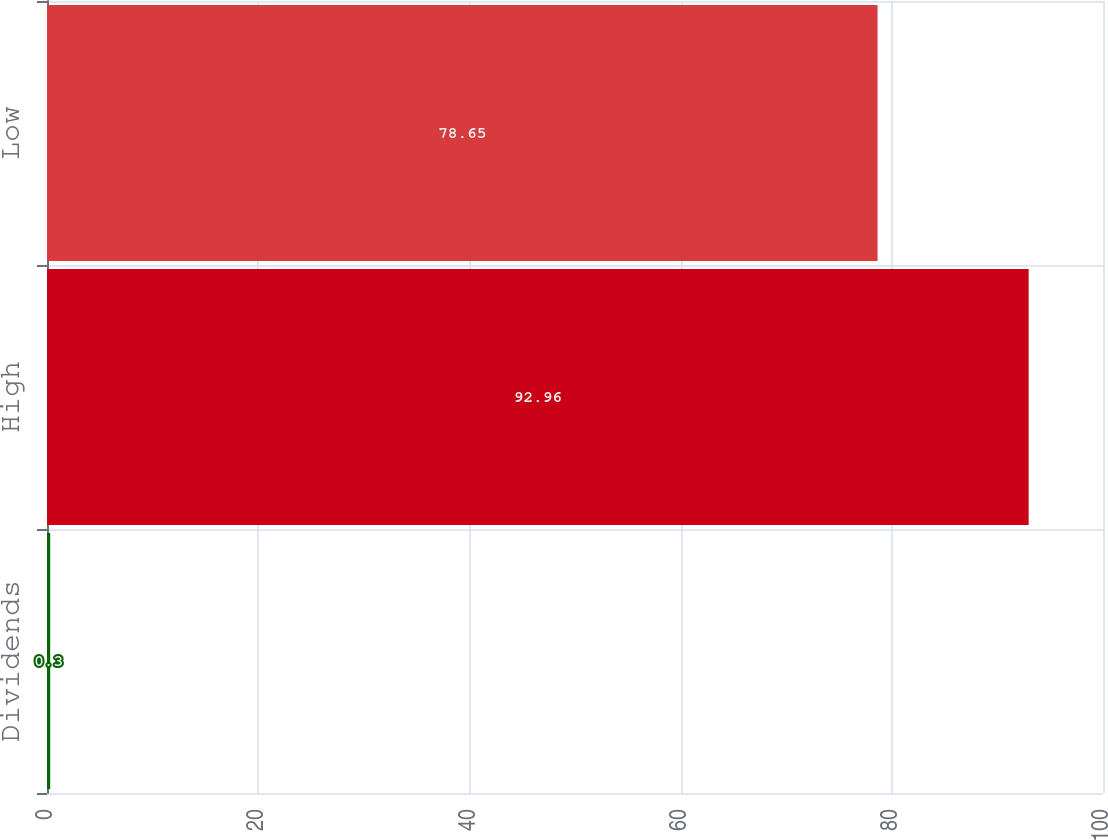Convert chart to OTSL. <chart><loc_0><loc_0><loc_500><loc_500><bar_chart><fcel>Dividends<fcel>High<fcel>Low<nl><fcel>0.3<fcel>92.96<fcel>78.65<nl></chart> 